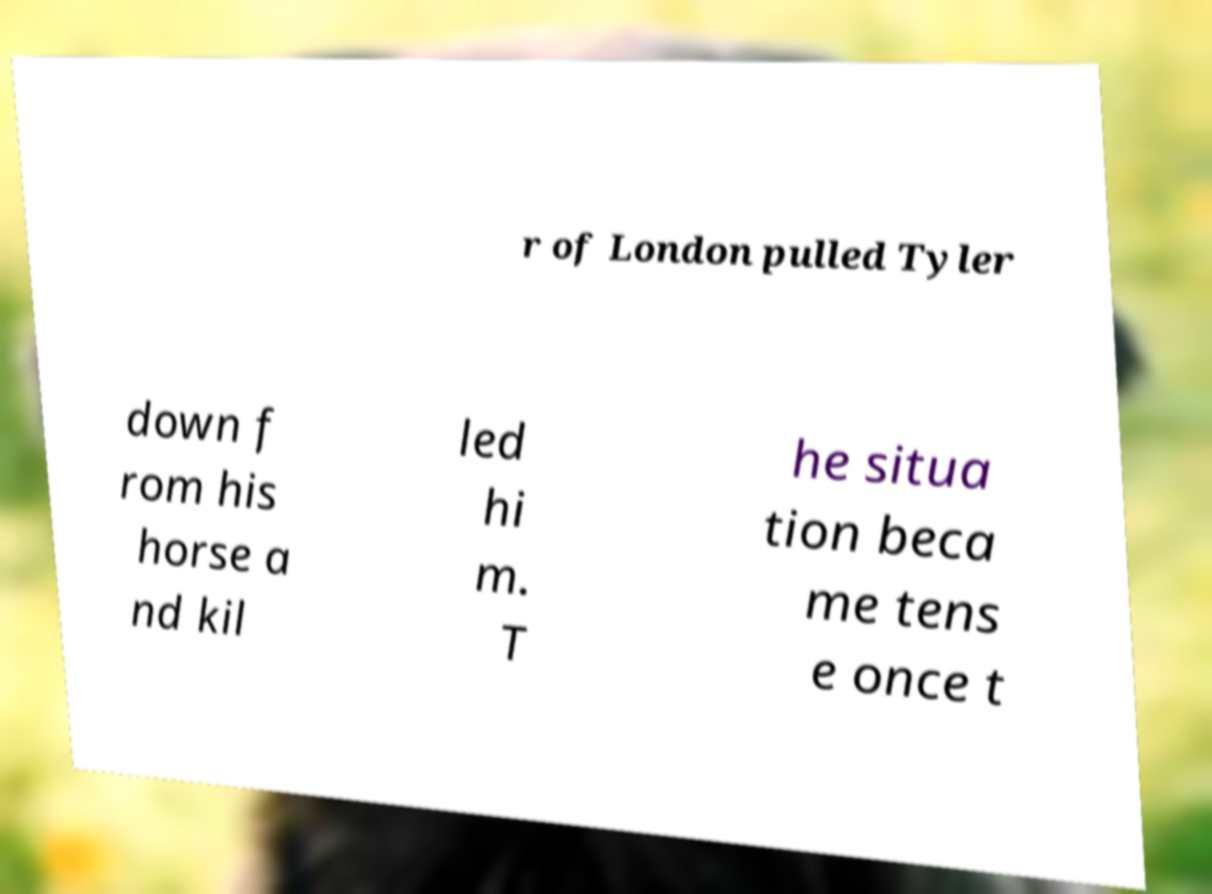What messages or text are displayed in this image? I need them in a readable, typed format. r of London pulled Tyler down f rom his horse a nd kil led hi m. T he situa tion beca me tens e once t 